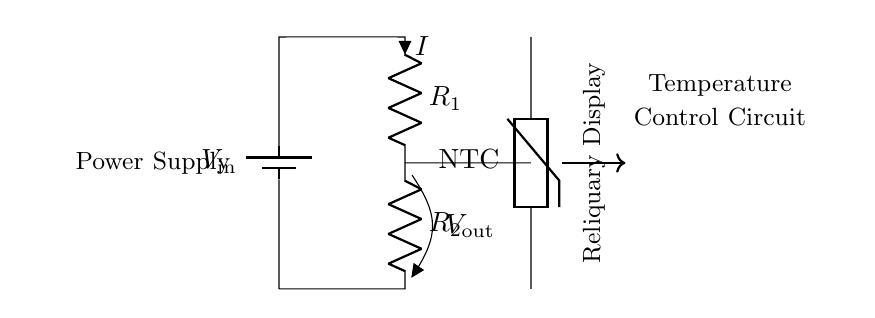What is the input voltage of this circuit? The input voltage, represented by the battery, is labeled as V_in. It must be specified in the circuit diagram.
Answer: V_in What are the resistances in the voltage divider? The voltage divider consists of two resistors, R_1 and R_2, which are in series. They are essential components for dividing the voltage output.
Answer: R_1, R_2 What is the output voltage of this system? The output voltage is indicated by V_out, which is the voltage across R_2. The voltage divider formula gives a proportion based on R_1 and R_2.
Answer: V_out Which component regulates the temperature of the display? The component that regulates the temperature in this circuit is the thermistor, specifically a Negative Temperature Coefficient (NTC) thermistor, which responds to temperature changes.
Answer: NTC How does the current flow in this circuit? The current flows from the positive terminal of the battery through R_1 and R_2 before returning to the battery. This series arrangement indicates a linear flow of current.
Answer: I What kind of circuit is shown here? This circuit is a voltage divider, which is used to obtain a desired lower voltage from a higher voltage source via resistors.
Answer: Voltage Divider 